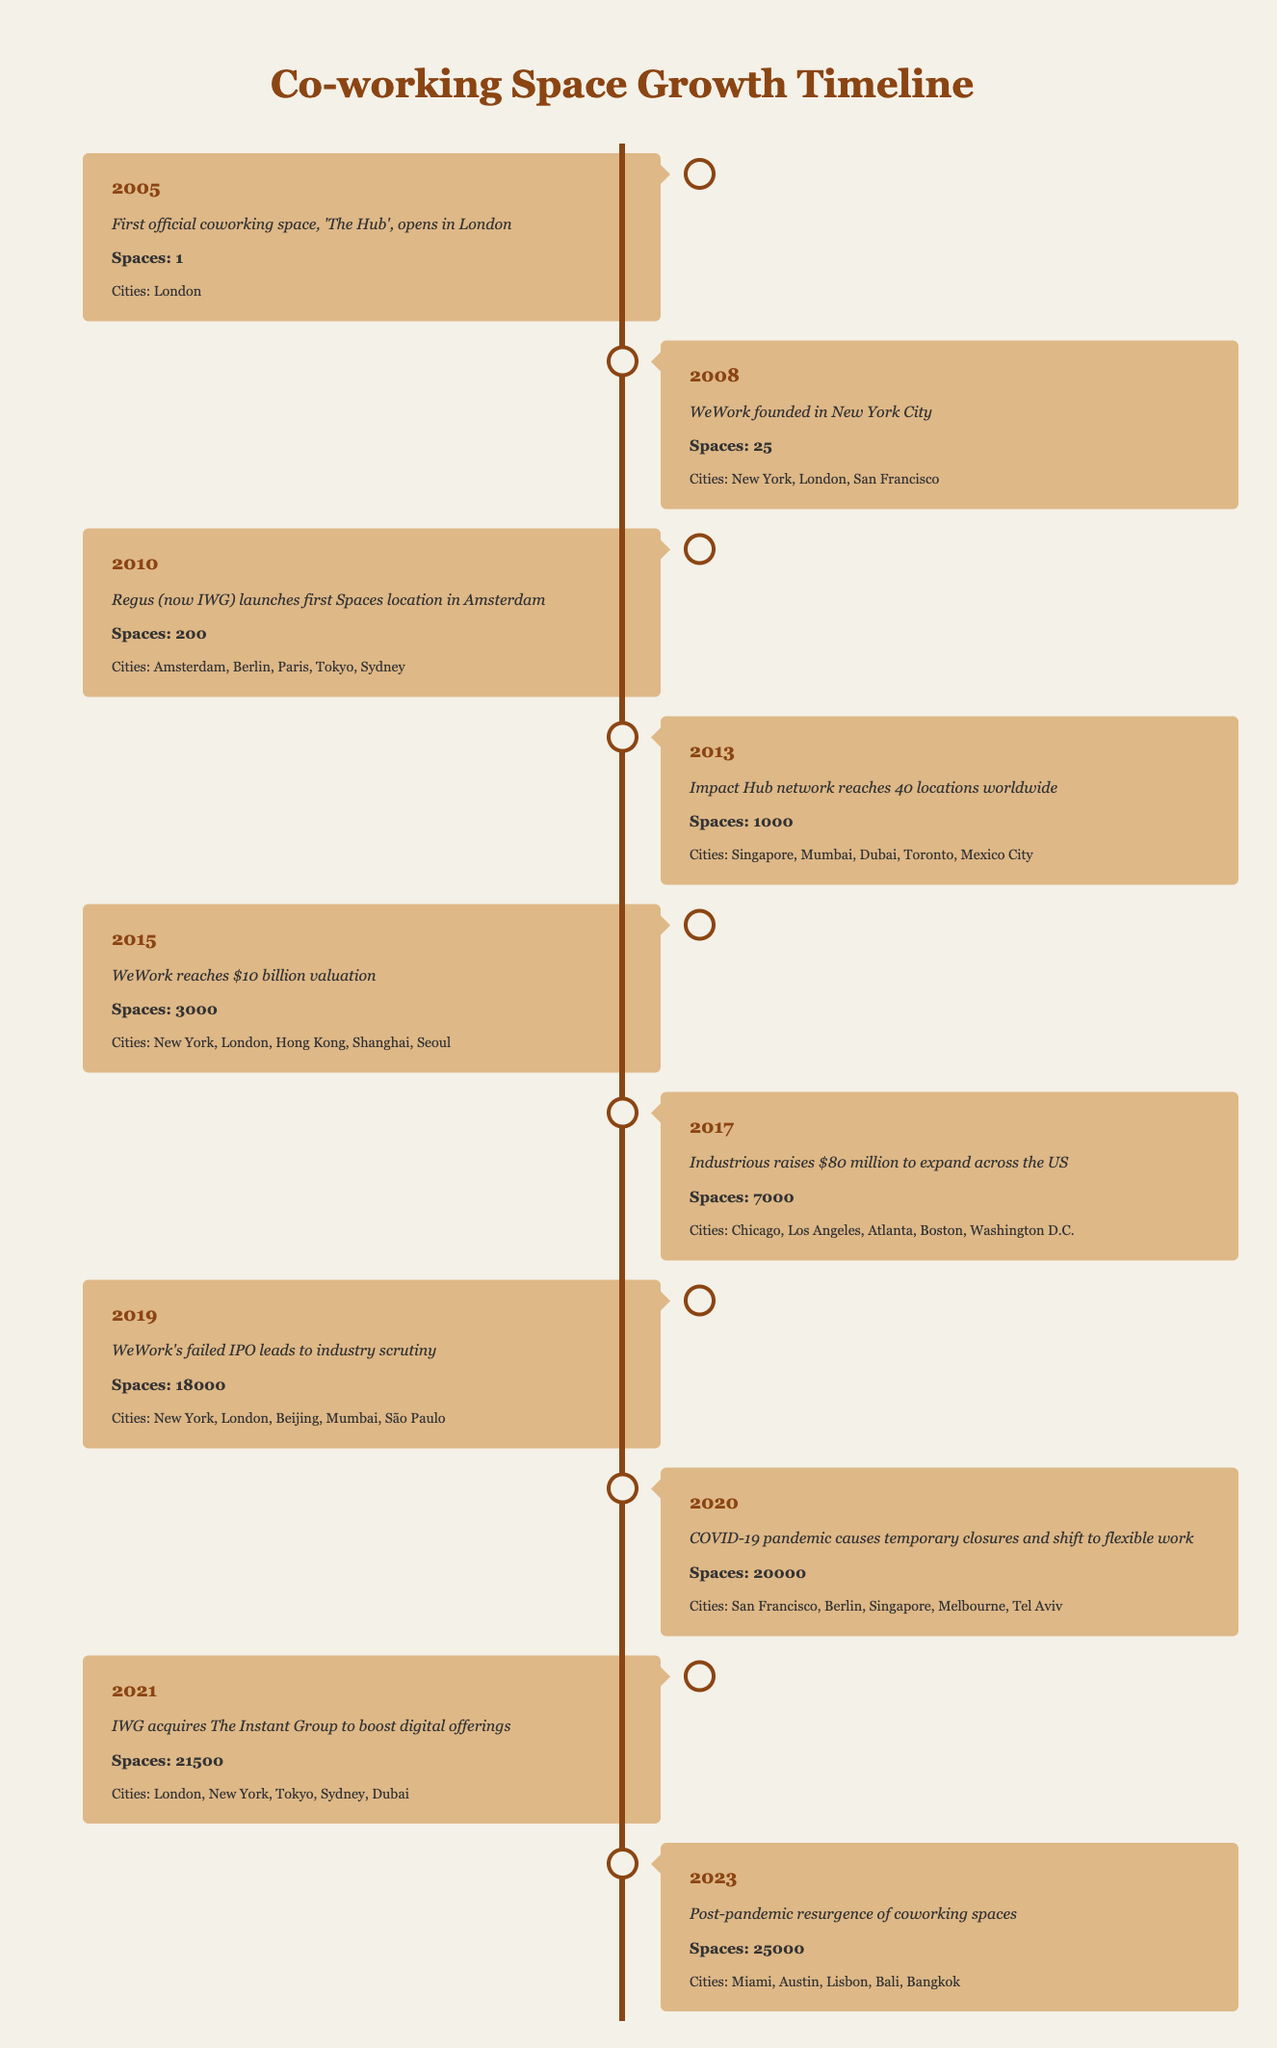What year did the first official coworking space open? The first official coworking space, 'The Hub', opened in London in 2005. This information is directly stated in the timeline for that year.
Answer: 2005 How many coworking spaces were there in 2010? According to the timeline, in 2010 there were 200 coworking spaces listed for cities including Amsterdam, Berlin, Paris, Tokyo, and Sydney.
Answer: 200 Which city had the most coworking spaces in 2023? The timeline shows that in 2023, there were coworking spaces in Miami, Austin, Lisbon, Bali, and Bangkok. However, it doesn't specify the number of spaces in each city. Thus, we can't determine which city had the most.
Answer: Cannot determine What is the difference in the number of spaces between 2015 and 2021? In 2015, the number of spaces was 3000, and in 2021 it increased to 21500. The difference is calculated by subtracting 3000 from 21500, resulting in 18500 additional spaces.
Answer: 18500 Did the number of coworking spaces ever decrease from 2005 to 2023? The timeline shows a continuous increase in the number of coworking spaces from 1 in 2005 to 25000 in 2023 without any decrease in values across the years.
Answer: No Which year saw the largest increase in coworking spaces? Analyzing the values, the largest increase occurred from 2019 to 2020, moving from 18000 to 20000 spaces, which is an increase of 2000 spaces. Other years had smaller increments; thus, this year experienced the most significant growth.
Answer: 2019 to 2020 What were the total coworking spaces across all years from 2005 to 2023? To find the total, we sum the number of spaces for each year: 1 + 25 + 200 + 1000 + 3000 + 7000 + 18000 + 20000 + 21500 + 25000 = 69936. Thus, the total coworking spaces over the years is 69936.
Answer: 69936 How many cities had coworking spaces in 2013? In 2013, the timeline specifies that the Impact Hub network reached 40 locations worldwide, which included cities such as Singapore, Mumbai, Dubai, Toronto, and Mexico City. The mention of a specific number of cities is not given in this context, but based on some well-known cities listed, there are at least 5.
Answer: At least 5 Was WeWork founded before or after the first coworking space opened? The data shows that 'The Hub' opened in 2005 and WeWork was founded in 2008, indicating that WeWork was established after the first coworking space.
Answer: After 